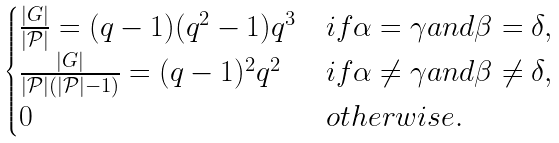<formula> <loc_0><loc_0><loc_500><loc_500>\begin{cases} \frac { | G | } { | \mathcal { P } | } = ( q - 1 ) ( q ^ { 2 } - 1 ) q ^ { 3 } & i f \alpha = \gamma a n d \beta = \delta , \\ \frac { | G | } { | \mathcal { P } | ( | \mathcal { P } | - 1 ) } = ( q - 1 ) ^ { 2 } q ^ { 2 } & i f \alpha \neq \gamma a n d \beta \neq \delta , \\ 0 & o t h e r w i s e . \end{cases}</formula> 